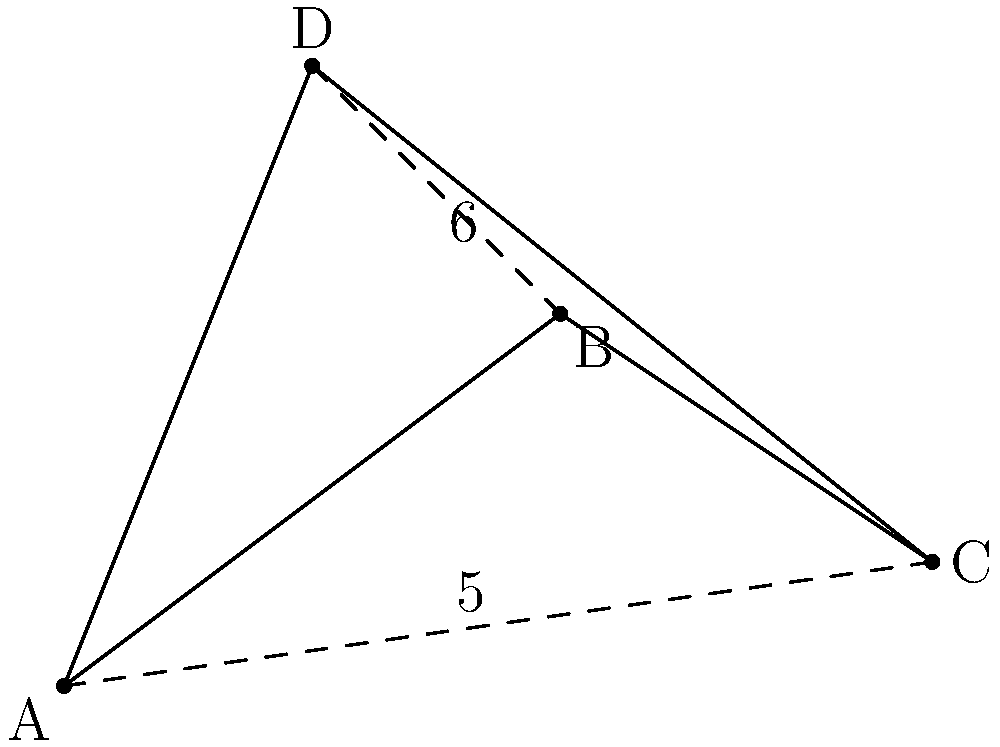In your UWP application for optimizing delivery routes, you're presented with a quadrilateral ABCD representing four delivery locations. The diagonal AC has a length of 5 units, and BD has a length of 6 units. Using vector operations, determine the area of the quadrilateral ABCD to identify the most efficient delivery zone. To find the area of quadrilateral ABCD using vector operations, we can follow these steps:

1) Let's define vectors $\vec{AC}$ and $\vec{BD}$ as the diagonals of the quadrilateral.

2) The area of a parallelogram formed by two vectors is given by the magnitude of their cross product. In this case, half of this area will give us the area of the quadrilateral.

3) The formula for the area is:
   Area = $\frac{1}{2}|\vec{AC} \times \vec{BD}|$

4) We don't have the actual vector components, but we know the magnitudes:
   $|\vec{AC}| = 5$ and $|\vec{BD}| = 6$

5) The magnitude of the cross product is given by:
   $|\vec{AC} \times \vec{BD}| = |\vec{AC}||\vec{BD}|\sin\theta$
   where $\theta$ is the angle between the vectors.

6) We don't know $\theta$, but we can find $\sin\theta$ using the given information:
   $\sin\theta = \frac{2\text{ Area of quadrilateral}}{|\vec{AC}||\vec{BD}|}$

7) Substituting this into our area formula:
   Area = $\frac{1}{2}(5)(6)\sin\theta = 15\sin\theta$

8) The maximum possible area occurs when $\sin\theta = 1$, i.e., when the diagonals are perpendicular.

Therefore, the maximum possible area of the quadrilateral is 15 square units.
Answer: 15 square units 